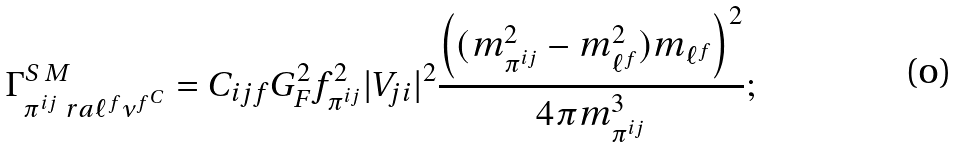Convert formula to latex. <formula><loc_0><loc_0><loc_500><loc_500>\Gamma ^ { S \, M } _ { \pi ^ { i j } \ r a \ell ^ { f } { \nu ^ { f } } ^ { C } } = C _ { i j f } G _ { F } ^ { 2 } f _ { \pi ^ { i j } } ^ { 2 } | V _ { j i } | ^ { 2 } \frac { \left ( ( m _ { \pi ^ { i j } } ^ { 2 } - m _ { \ell ^ { f } } ^ { 2 } ) m _ { \ell ^ { f } } \right ) ^ { 2 } } { 4 \pi m _ { \pi ^ { i j } } ^ { 3 } } ;</formula> 